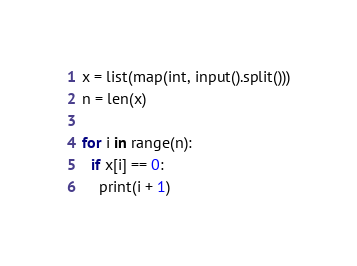Convert code to text. <code><loc_0><loc_0><loc_500><loc_500><_Python_>x = list(map(int, input().split()))
n = len(x)

for i in range(n):
  if x[i] == 0:
    print(i + 1)
</code> 